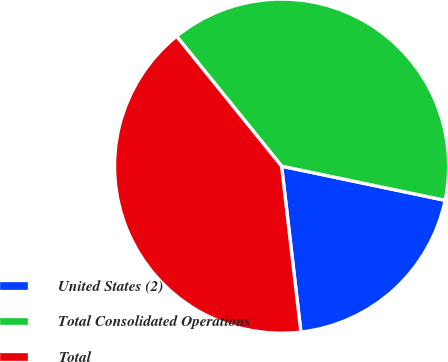Convert chart to OTSL. <chart><loc_0><loc_0><loc_500><loc_500><pie_chart><fcel>United States (2)<fcel>Total Consolidated Operations<fcel>Total<nl><fcel>19.88%<fcel>39.1%<fcel>41.02%<nl></chart> 